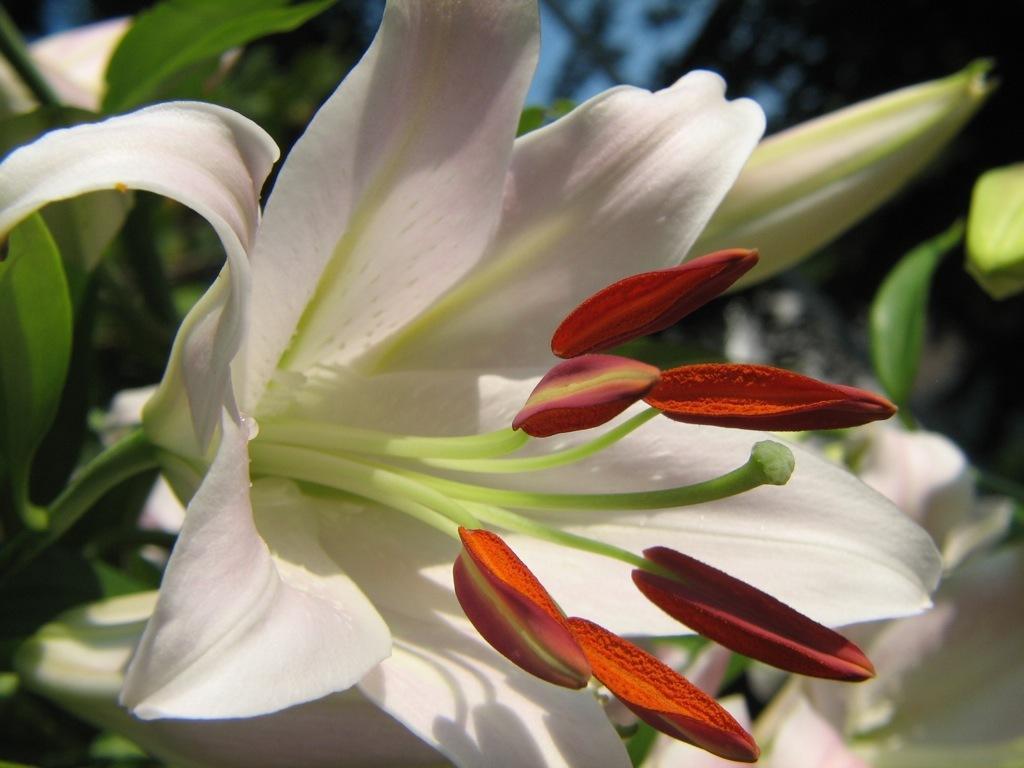Describe this image in one or two sentences. In this image we can see a white lily flower. Also there are buds. In the background it is looking blur. 